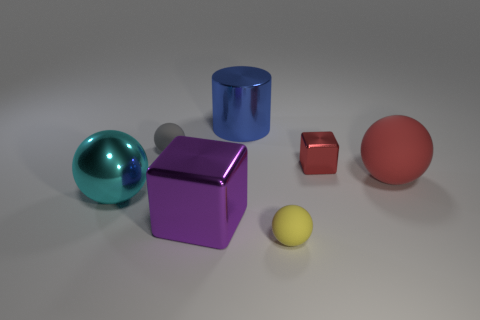Do the tiny yellow rubber thing and the purple thing have the same shape?
Offer a very short reply. No. What number of rubber objects are either big cubes or red blocks?
Give a very brief answer. 0. The big metal block in front of the blue object is what color?
Keep it short and to the point. Purple. There is another rubber thing that is the same size as the blue thing; what is its shape?
Provide a succinct answer. Sphere. There is a small block; is it the same color as the rubber object on the right side of the yellow sphere?
Ensure brevity in your answer.  Yes. How many objects are either large cyan objects that are in front of the small red shiny cube or spheres that are on the right side of the blue cylinder?
Offer a terse response. 3. There is a red object that is the same size as the purple block; what material is it?
Ensure brevity in your answer.  Rubber. What number of other objects are there of the same material as the large blue object?
Make the answer very short. 3. Is the shape of the red object that is behind the large red matte thing the same as the purple object in front of the red rubber ball?
Make the answer very short. Yes. What color is the small rubber sphere that is on the right side of the tiny rubber sphere behind the matte ball that is in front of the large cyan metallic sphere?
Provide a succinct answer. Yellow. 